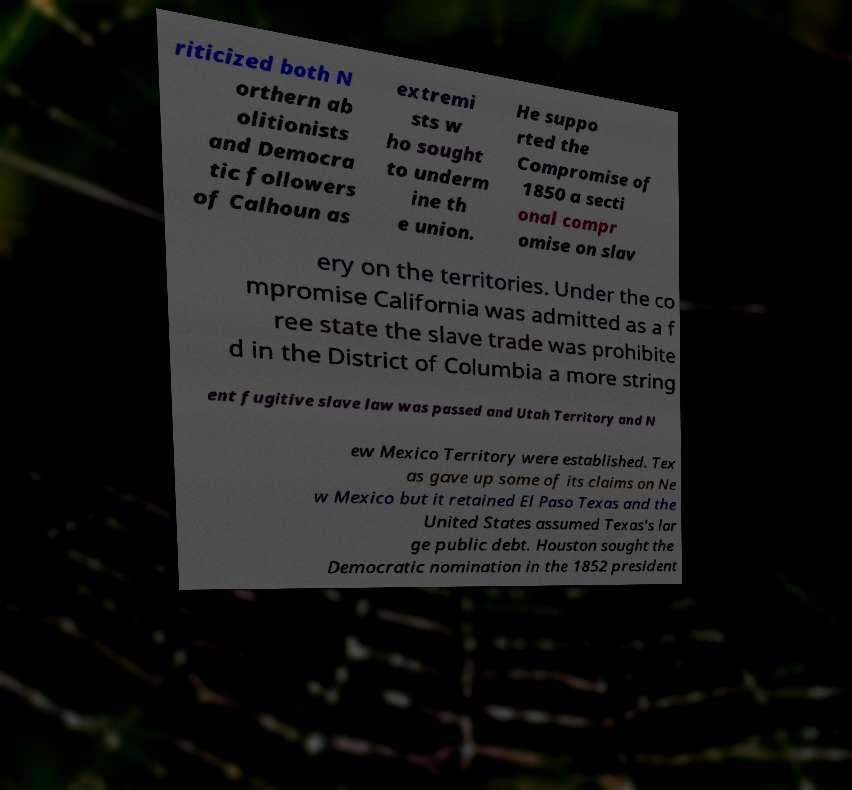For documentation purposes, I need the text within this image transcribed. Could you provide that? riticized both N orthern ab olitionists and Democra tic followers of Calhoun as extremi sts w ho sought to underm ine th e union. He suppo rted the Compromise of 1850 a secti onal compr omise on slav ery on the territories. Under the co mpromise California was admitted as a f ree state the slave trade was prohibite d in the District of Columbia a more string ent fugitive slave law was passed and Utah Territory and N ew Mexico Territory were established. Tex as gave up some of its claims on Ne w Mexico but it retained El Paso Texas and the United States assumed Texas's lar ge public debt. Houston sought the Democratic nomination in the 1852 president 